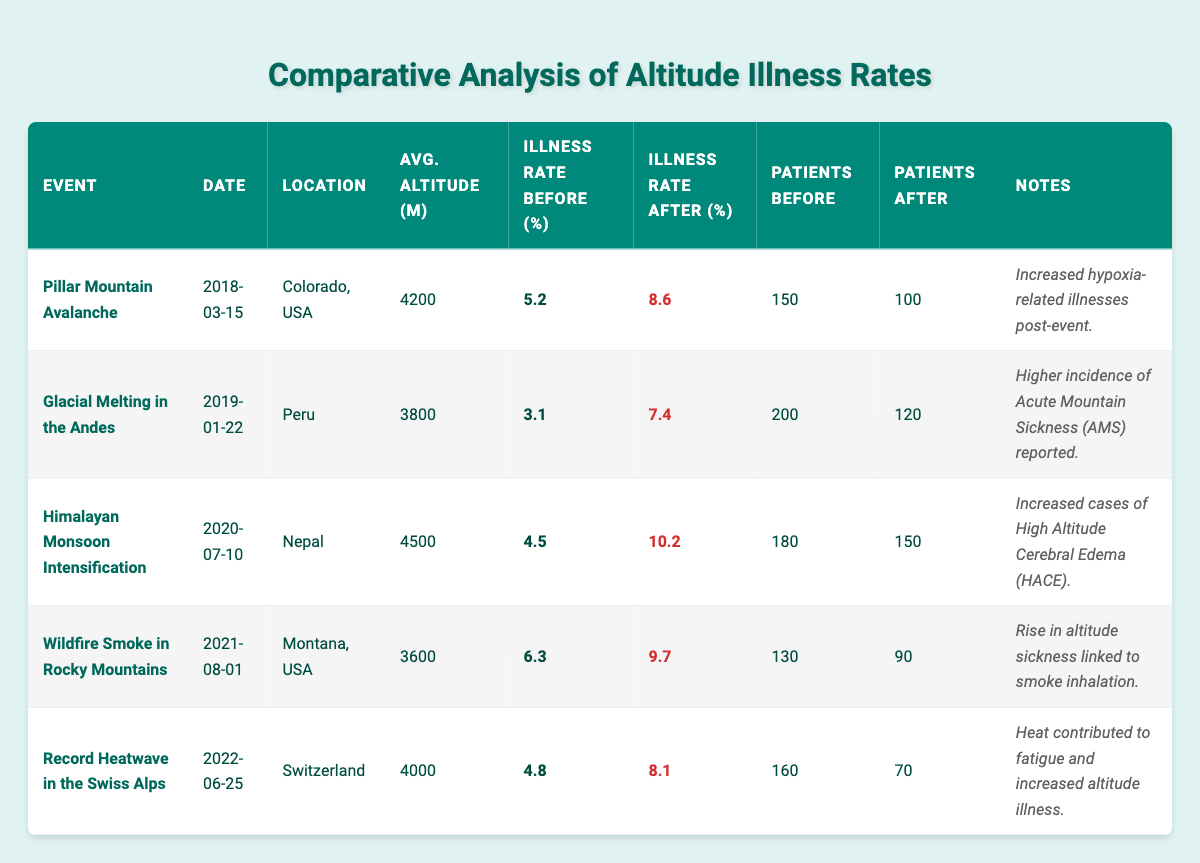What was the illness rate before the Pillar Mountain Avalanche event? The illness rate before the Pillar Mountain Avalanche event is directly available in the corresponding row of the table, which states it as 5.2%.
Answer: 5.2% What is the illness rate after the Glacial Melting in the Andes? The table shows the illness rate after the Glacial Melting in the Andes event as 7.4%, listed in the relevant row.
Answer: 7.4% What is the average altitude of patients affected during the Himalayan Monsoon Intensification event? The table provides the average altitude for this event as 4500 meters, which is explicitly indicated in the corresponding row.
Answer: 4500 m How many total patients were there before the Wildfire Smoke event? The number of patients before the Wildfire Smoke in Rocky Mountains event is listed in the table as 130, found in its respective row and column.
Answer: 130 Did the illness rate significantly increase after the Record Heatwave in the Swiss Alps? Yes, the illness rate increased from 4.8% before the event to 8.1% after the event, indicating a notable increase of 3.3%.
Answer: Yes Which event had the highest increase in illness rate? To find this, we can calculate the increases for each event: Pillar Mountain Avalanche (3.4), Glacial Melting in the Andes (4.3), Himalayan Monsoon Intensification (5.7), Wildfire Smoke (3.4), and Record Heatwave (3.3). The Himalayan Monsoon Intensification had the highest increase of 5.7%.
Answer: Himalayan Monsoon Intensification How many total patients were there after the Glacial Melting in the Andes? The table indicates the number of total patients after the Glacial Melting in the Andes event as 120, as found in the specific row for that event.
Answer: 120 What is the difference between the average illness rates before and after the Pillar Mountain Avalanche? The difference in illness rates for this event is calculated by subtracting the rate before (5.2%) from the rate after (8.6%), which is 8.6 - 5.2 = 3.4%.
Answer: 3.4% Were there more total patients before the Himalayan Monsoon Intensification compared to after? Yes, there were 180 patients before the event and 150 after the event, showing that the number of patients decreased.
Answer: Yes 